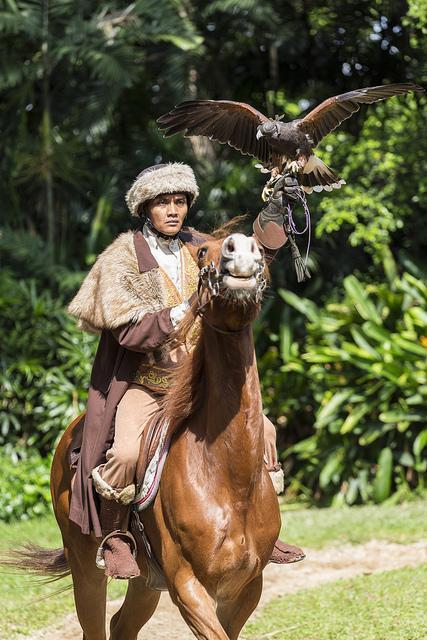How many bus cars can you see?
Give a very brief answer. 0. 